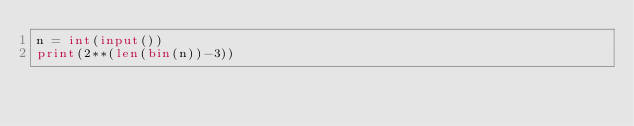<code> <loc_0><loc_0><loc_500><loc_500><_Python_>n = int(input())
print(2**(len(bin(n))-3))</code> 